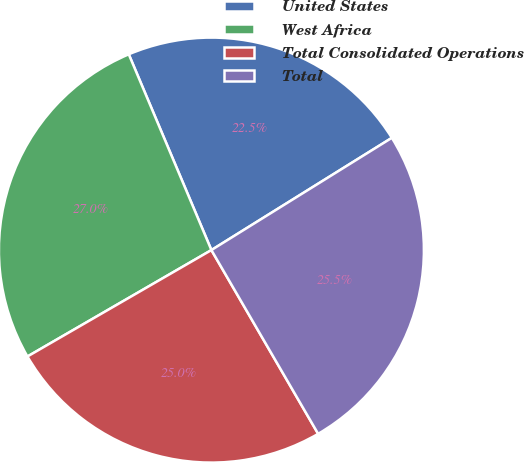Convert chart to OTSL. <chart><loc_0><loc_0><loc_500><loc_500><pie_chart><fcel>United States<fcel>West Africa<fcel>Total Consolidated Operations<fcel>Total<nl><fcel>22.5%<fcel>26.99%<fcel>25.03%<fcel>25.48%<nl></chart> 